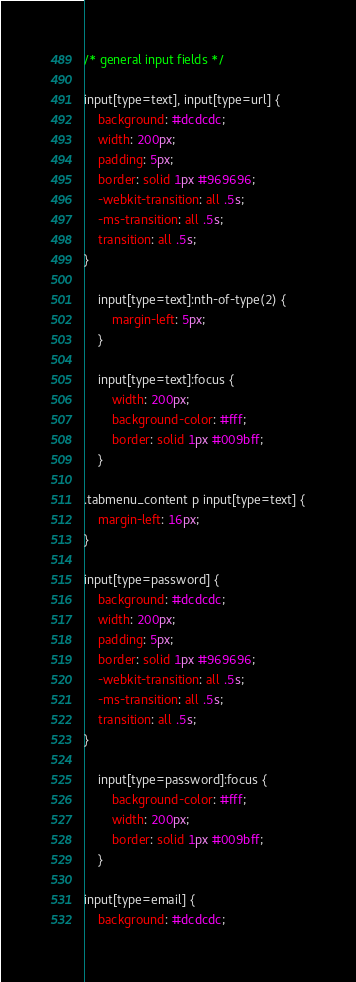Convert code to text. <code><loc_0><loc_0><loc_500><loc_500><_CSS_>/* general input fields */

input[type=text], input[type=url] {
    background: #dcdcdc;
    width: 200px;
    padding: 5px;
    border: solid 1px #969696;
    -webkit-transition: all .5s;
    -ms-transition: all .5s;
    transition: all .5s;
}

    input[type=text]:nth-of-type(2) {
        margin-left: 5px;
    }

    input[type=text]:focus {
        width: 200px;
        background-color: #fff;
        border: solid 1px #009bff;
    }

.tabmenu_content p input[type=text] {
    margin-left: 16px;
}

input[type=password] {
    background: #dcdcdc;
    width: 200px;
    padding: 5px;
    border: solid 1px #969696;
    -webkit-transition: all .5s;
    -ms-transition: all .5s;
    transition: all .5s;
}

    input[type=password]:focus {
        background-color: #fff;
        width: 200px;
        border: solid 1px #009bff;
    }

input[type=email] {
    background: #dcdcdc;</code> 